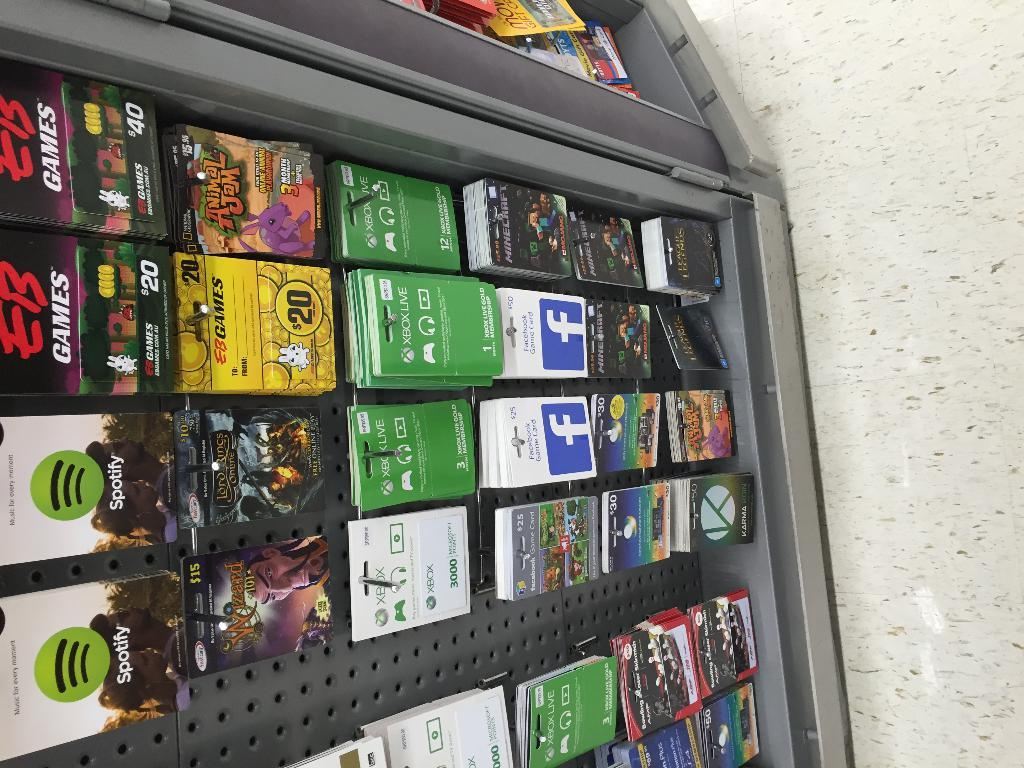<image>
Describe the image concisely. A display has hanging cards and the top one is Spotify. 